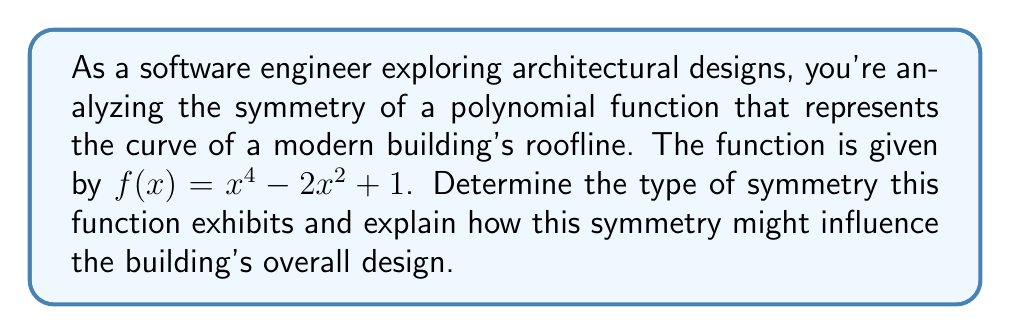Solve this math problem. Let's analyze the symmetry of the given polynomial function step-by-step:

1) To determine the symmetry, we need to check if the function is even, odd, or neither.

2) For even functions: $f(-x) = f(x)$ for all $x$
   For odd functions: $f(-x) = -f(x)$ for all $x$

3) Let's test $f(-x)$:
   $f(-x) = (-x)^4 - 2(-x)^2 + 1$
   
4) Simplify:
   $f(-x) = x^4 - 2x^2 + 1$

5) We can see that $f(-x) = f(x)$ for all $x$, which means this function is even.

6) Even functions are symmetric about the y-axis. This means if we draw a vertical line through the y-axis, the graph would be a mirror image on both sides.

7) In architectural terms, this symmetry translates to a design that would look the same whether viewed from the left or right side of the central axis.

8) The equation $x^4 - 2x^2 + 1$ creates a shape known as a "lemniscate" or figure-eight curve when rotated. This could inspire a flowing, curved roofline that dips in the middle and rises at the ends.

9) The symmetry in this design could influence:
   - Balance in the overall structure
   - Equal distribution of weight and forces
   - Aesthetic appeal through visual harmony
   - Potential for modular or repeating elements in the design
Answer: Even symmetry about the y-axis 